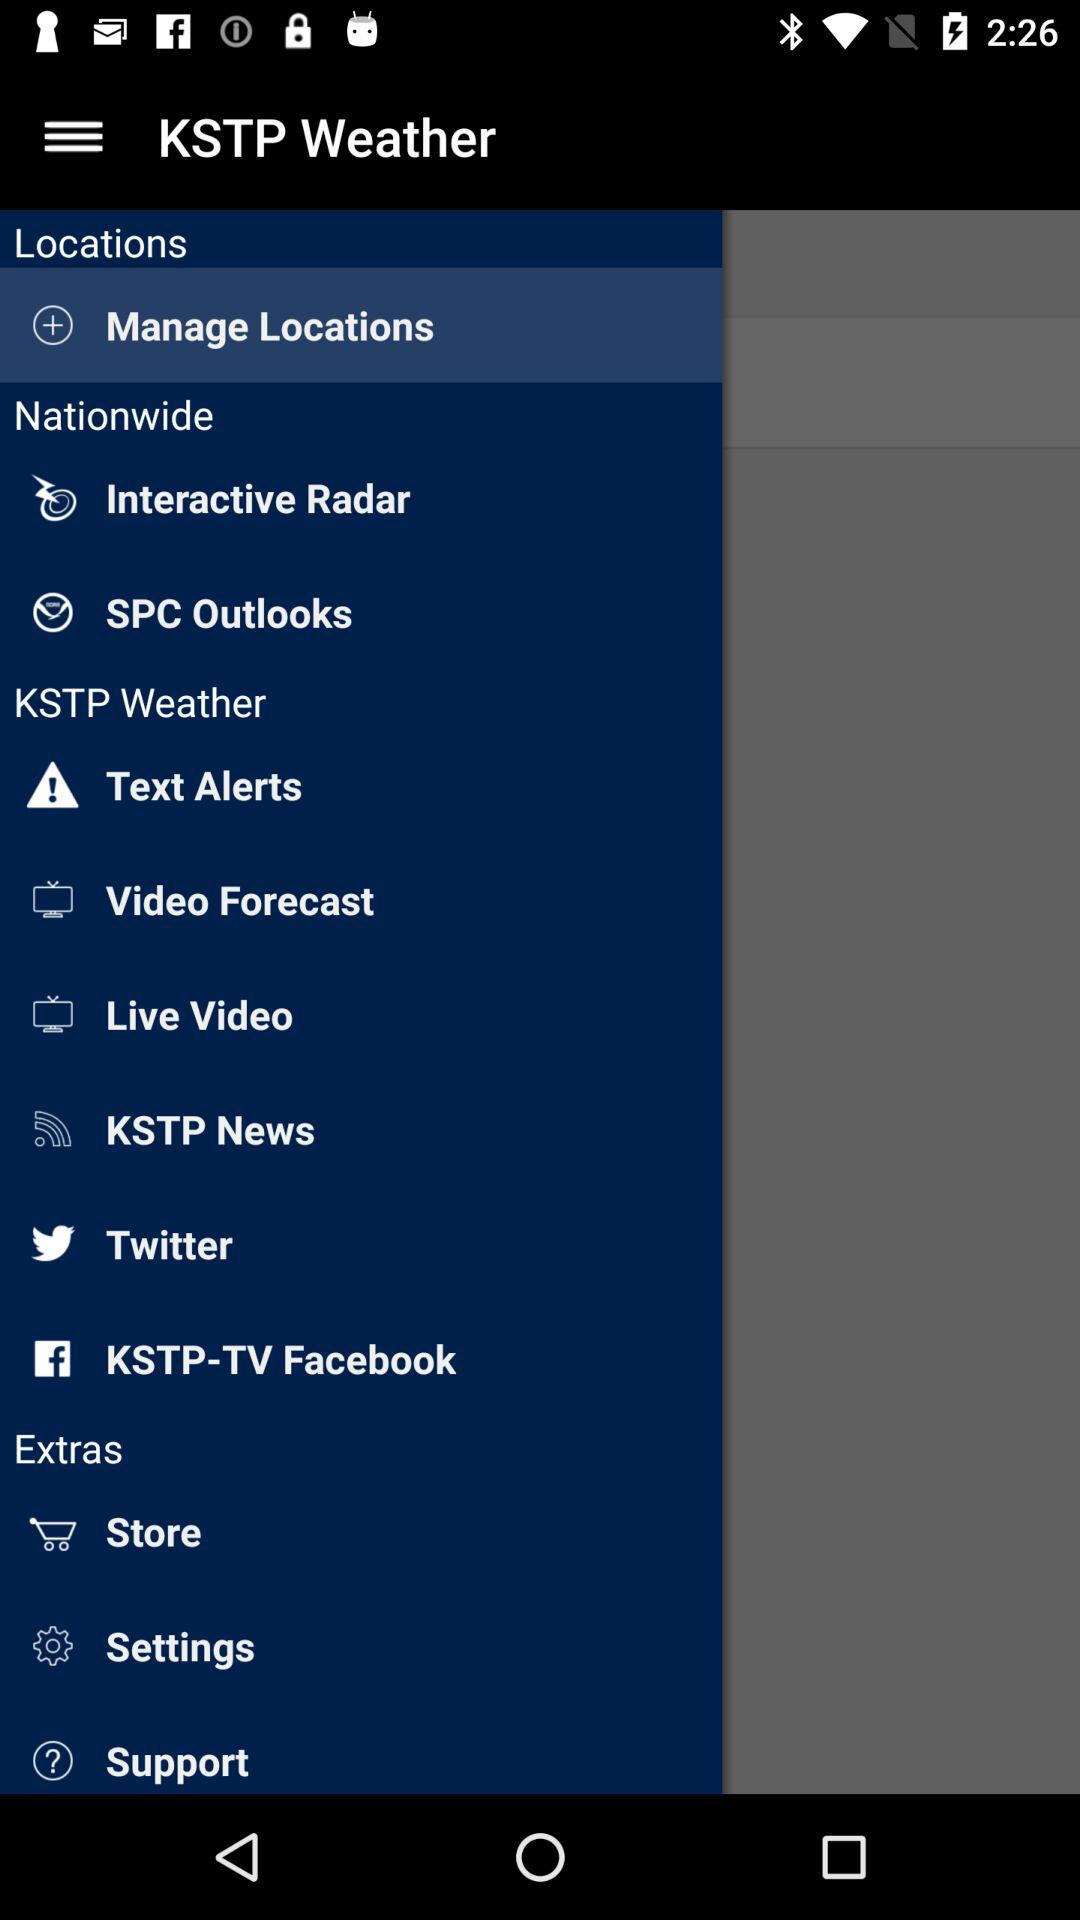Which is the selected item in the menu? The selected item is "Manage Locations". 